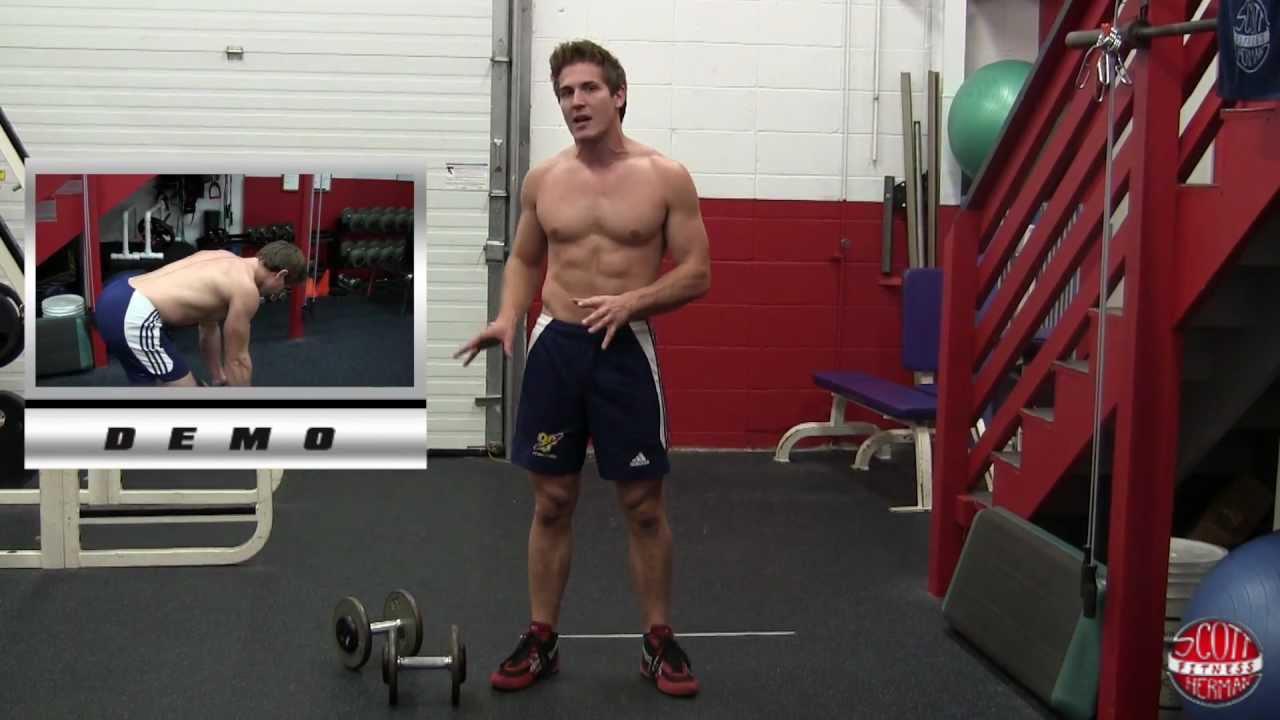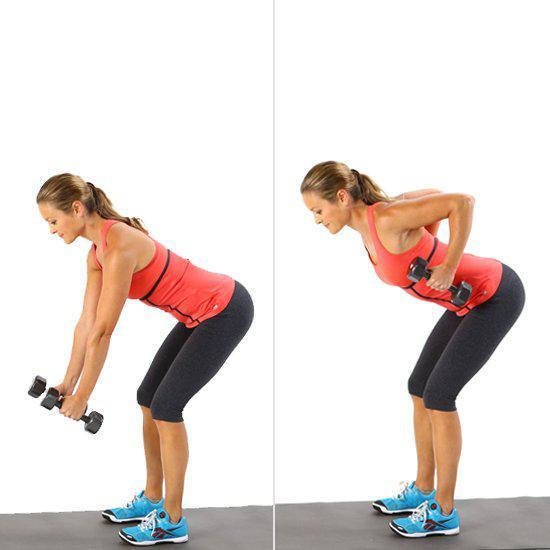The first image is the image on the left, the second image is the image on the right. For the images shown, is this caption "An image shows a woman bending forward while holding dumbell weights." true? Answer yes or no. Yes. The first image is the image on the left, the second image is the image on the right. For the images shown, is this caption "There is no less than one woman lifting weights" true? Answer yes or no. Yes. 